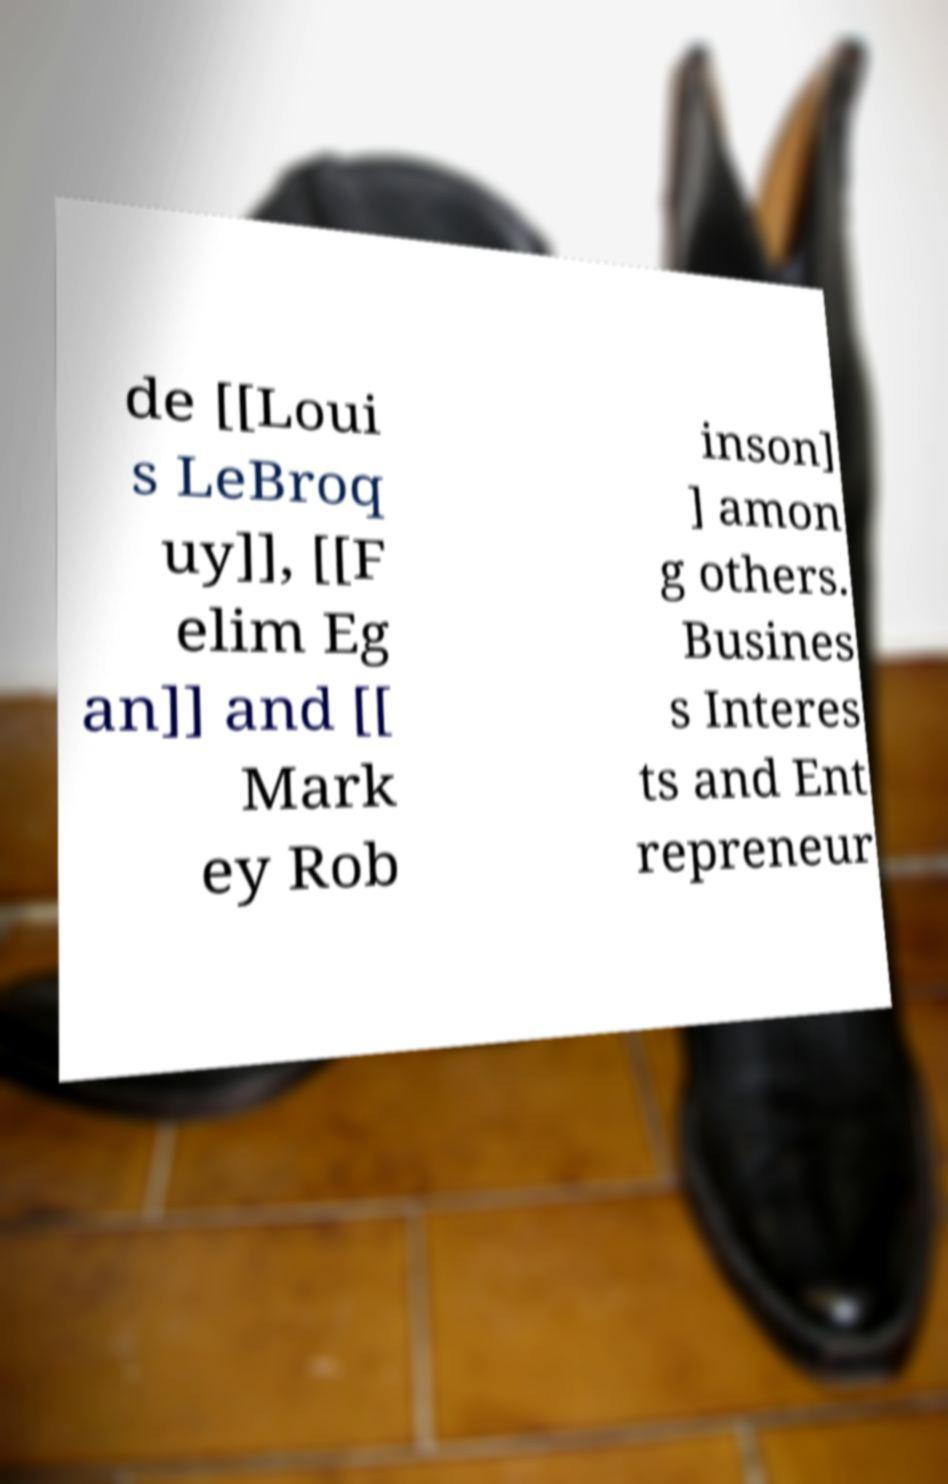Could you assist in decoding the text presented in this image and type it out clearly? de [[Loui s LeBroq uy]], [[F elim Eg an]] and [[ Mark ey Rob inson] ] amon g others. Busines s Interes ts and Ent repreneur 